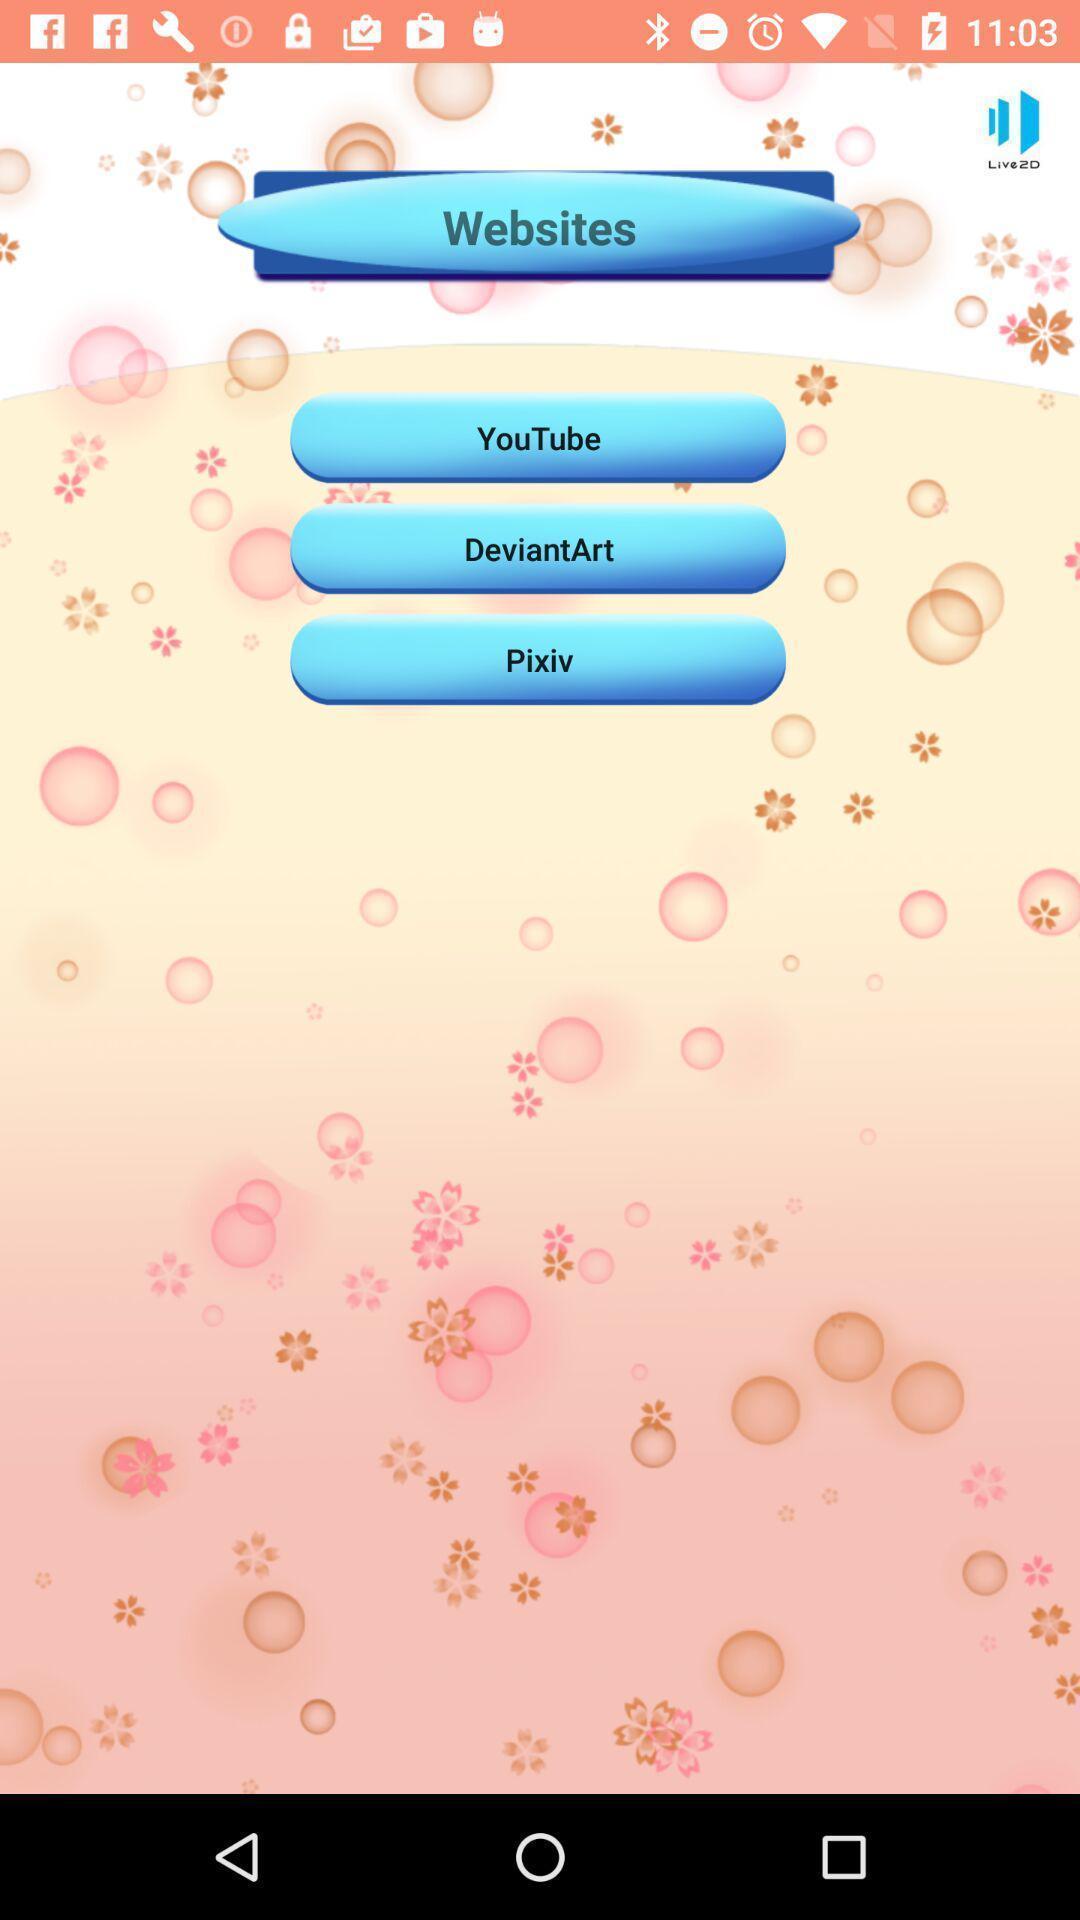Explain what's happening in this screen capture. Screen displaying multiple features. 